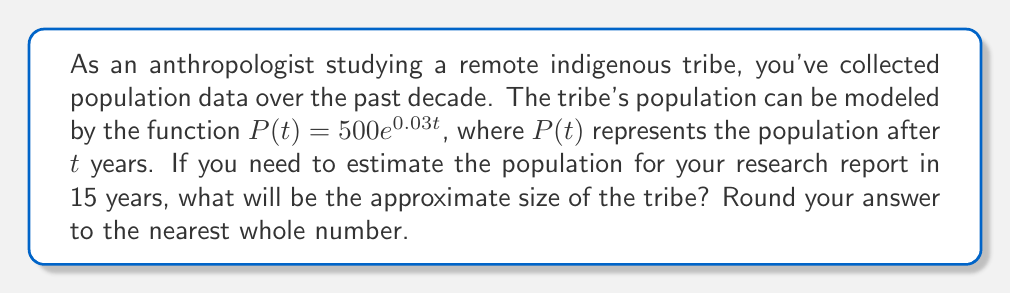Could you help me with this problem? To solve this problem, we'll follow these steps:

1) We're given the exponential function $P(t) = 500e^{0.03t}$, where:
   - 500 is the initial population
   - 0.03 is the growth rate
   - $t$ is the time in years

2) We need to find $P(15)$, as we're asked about the population after 15 years.

3) Let's substitute $t = 15$ into our function:

   $P(15) = 500e^{0.03(15)}$

4) Now, let's calculate this:
   
   $P(15) = 500e^{0.45}$

5) Using a calculator or computer:

   $500e^{0.45} \approx 500 \times 1.568345$
                $\approx 784.1725$

6) Rounding to the nearest whole number:

   784.1725 rounds to 784

Therefore, after 15 years, the tribe's population is estimated to be approximately 784 people.
Answer: 784 people 